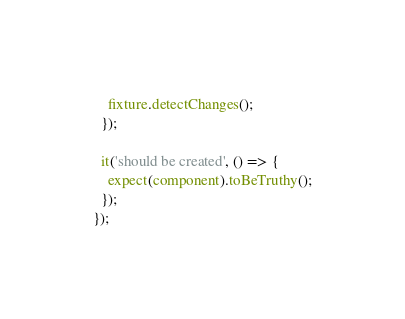Convert code to text. <code><loc_0><loc_0><loc_500><loc_500><_TypeScript_>    fixture.detectChanges();
  });

  it('should be created', () => {
    expect(component).toBeTruthy();
  });
});
</code> 